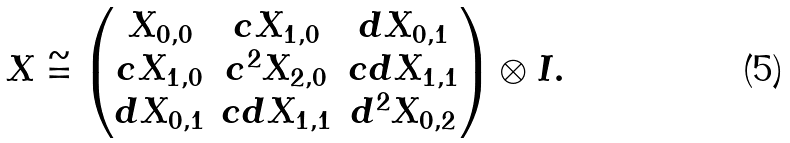<formula> <loc_0><loc_0><loc_500><loc_500>X \cong \begin{pmatrix} X _ { 0 , 0 } & c X _ { 1 , 0 } & d X _ { 0 , 1 } \\ c X _ { 1 , 0 } & c ^ { 2 } X _ { 2 , 0 } & c d X _ { 1 , 1 } \\ d X _ { 0 , 1 } & c d X _ { 1 , 1 } & d ^ { 2 } X _ { 0 , 2 } \end{pmatrix} \otimes I .</formula> 